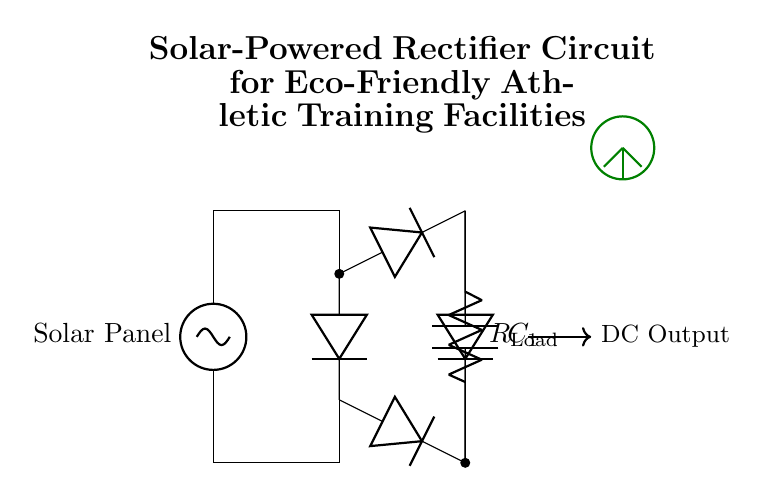What type of circuit is depicted? The circuit is a rectifier circuit, specifically a solar-powered bridge rectifier, which converts alternating current from a solar panel into direct current.
Answer: Rectifier What component is used to store energy? The component used to store energy in this circuit is a capacitor, labeled C1, which smooths out the fluctuations in the output voltage after rectification.
Answer: Capacitor How many diodes are used in the circuit? There are four diodes used in the bridge rectifier configuration, which allows current to flow in either direction, effectively converting AC to DC.
Answer: Four What is the purpose of the load resistor? The load resistor, labeled R_Load, is used to represent the component or device that consumes the output power from the rectifier, allowing us to measure the output current and voltage.
Answer: To represent load What does the solar panel supply? The solar panel supplies an alternating current that is then converted to direct current by the rectifier circuit, enabling the use of solar energy in the facility.
Answer: Alternating current What is the output type of this rectifier circuit? The output of this rectifier circuit is direct current, as indicated by the arrows showing the direction of current flow towards the DC output.
Answer: Direct current What beneficial feature does this circuit provide for training facilities? This circuit allows for the utilization of renewable solar energy, making it an eco-friendly option for powering athletic training facilities, thereby reducing their carbon footprint.
Answer: Eco-friendly power 